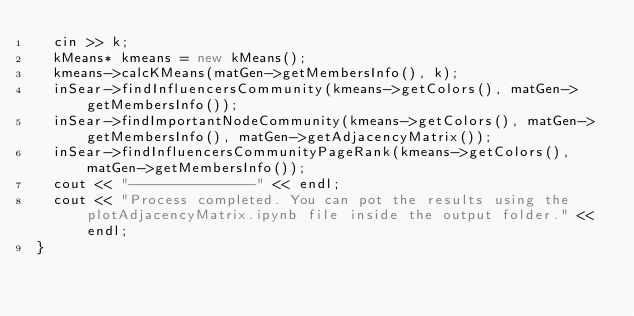<code> <loc_0><loc_0><loc_500><loc_500><_C++_>  cin >> k;
  kMeans* kmeans = new kMeans();
  kmeans->calcKMeans(matGen->getMembersInfo(), k);
  inSear->findInfluencersCommunity(kmeans->getColors(), matGen->getMembersInfo());
  inSear->findImportantNodeCommunity(kmeans->getColors(), matGen->getMembersInfo(), matGen->getAdjacencyMatrix());
  inSear->findInfluencersCommunityPageRank(kmeans->getColors(), matGen->getMembersInfo());
  cout << "---------------" << endl;
  cout << "Process completed. You can pot the results using the plotAdjacencyMatrix.ipynb file inside the output folder." << endl;
}
</code> 